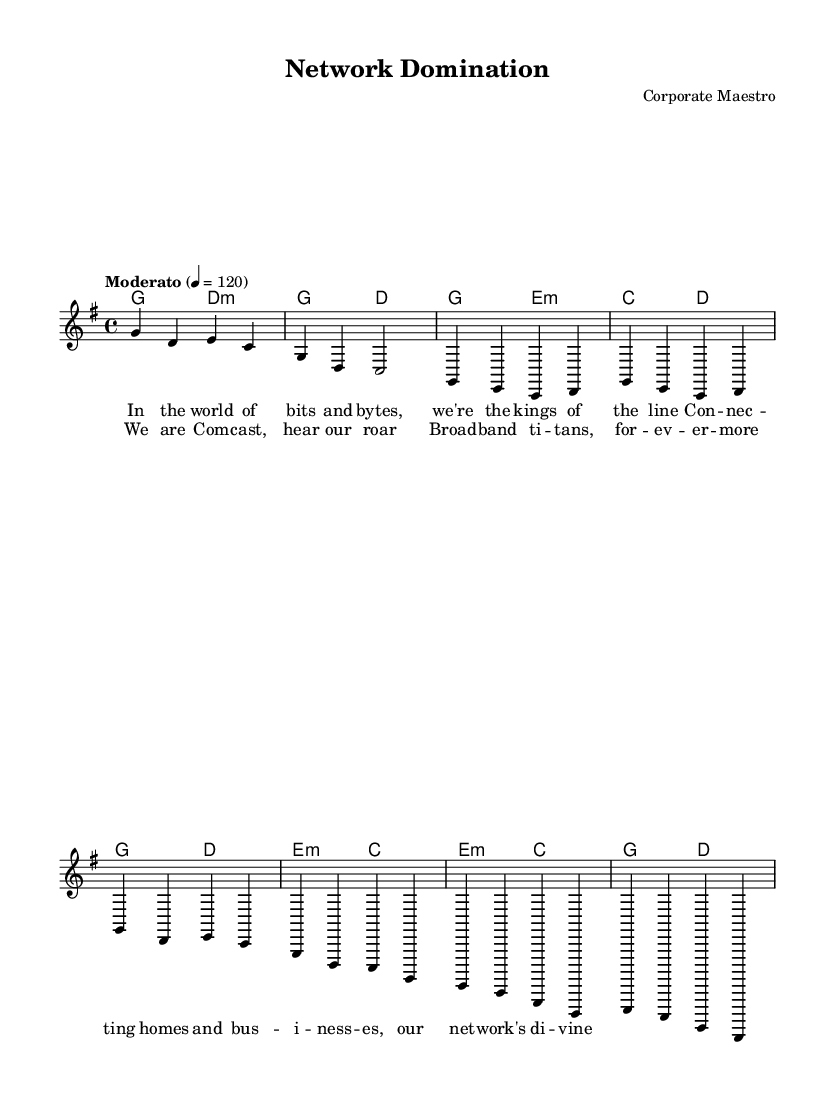What is the key signature of this music? The key signature is indicated by the absence of sharps or flats, which places it in G major.
Answer: G major What is the time signature of this music? The time signature appears at the beginning of the score, stating it is in 4/4 time, meaning there are four beats in each measure.
Answer: 4/4 What is the tempo of this piece? The tempo is shown as "Moderato" with a metronome marking of 120 beats per minute, indicating a moderate speed.
Answer: Moderato, 120 How many measures are present in the verse section? By counting the measures specifically labeled in the verse section, we can see there are 8 measures total.
Answer: 8 What chord is played during the chorus? The chord names above the melody indicate that the chorus starts with a G chord, as shown at the beginning of the chorus lyrics.
Answer: G chord What is the last lyric of the bridge section? The bridge contains lyrics that state the last phrase is "g four", leading us to understand that this is the final lyric sung in that section.
Answer: g four What is the overall theme conveyed in the lyrics? The lyrics highlight the themes of connectivity and domination in the corporate world, emphasizing the power of Comcast.
Answer: Connectivity and corporate power 